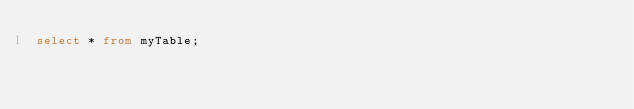<code> <loc_0><loc_0><loc_500><loc_500><_SQL_>select * from myTable;
</code> 